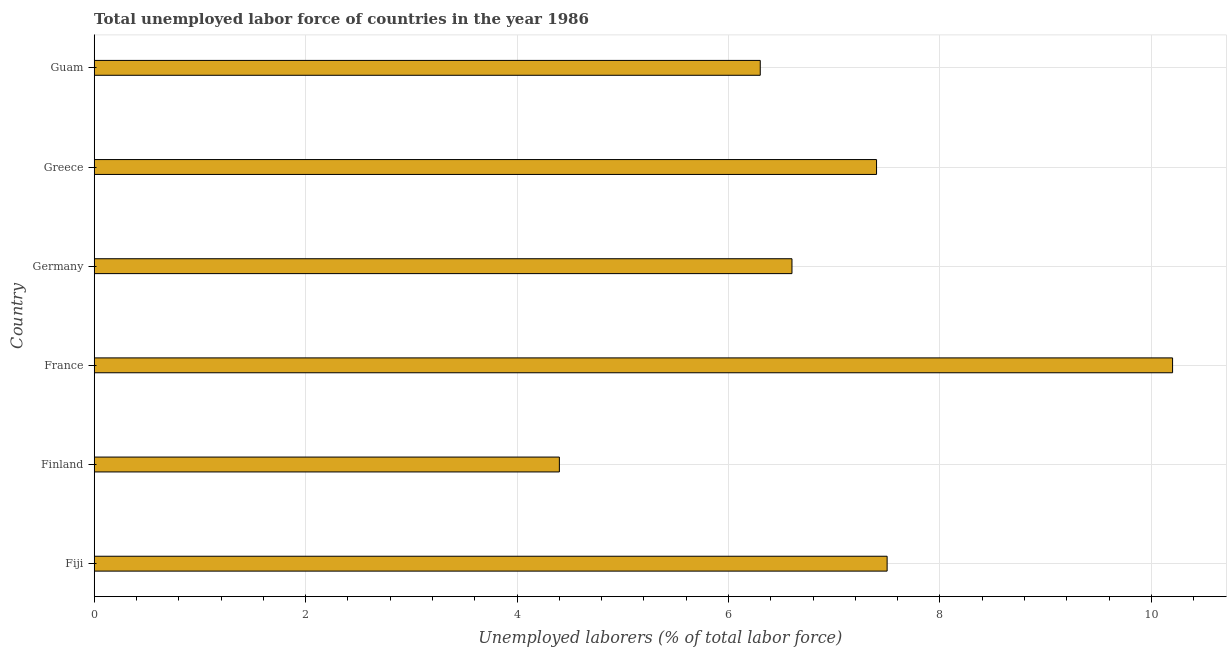Does the graph contain grids?
Your answer should be compact. Yes. What is the title of the graph?
Offer a very short reply. Total unemployed labor force of countries in the year 1986. What is the label or title of the X-axis?
Offer a terse response. Unemployed laborers (% of total labor force). What is the total unemployed labour force in Germany?
Keep it short and to the point. 6.6. Across all countries, what is the maximum total unemployed labour force?
Offer a very short reply. 10.2. Across all countries, what is the minimum total unemployed labour force?
Your answer should be compact. 4.4. In which country was the total unemployed labour force minimum?
Your answer should be compact. Finland. What is the sum of the total unemployed labour force?
Keep it short and to the point. 42.4. What is the difference between the total unemployed labour force in Finland and France?
Your answer should be very brief. -5.8. What is the average total unemployed labour force per country?
Your response must be concise. 7.07. What is the ratio of the total unemployed labour force in Germany to that in Guam?
Offer a very short reply. 1.05. What is the difference between the highest and the second highest total unemployed labour force?
Provide a succinct answer. 2.7. Is the sum of the total unemployed labour force in Fiji and Guam greater than the maximum total unemployed labour force across all countries?
Provide a succinct answer. Yes. What is the difference between the highest and the lowest total unemployed labour force?
Provide a succinct answer. 5.8. How many bars are there?
Your answer should be very brief. 6. What is the Unemployed laborers (% of total labor force) of Fiji?
Ensure brevity in your answer.  7.5. What is the Unemployed laborers (% of total labor force) of Finland?
Make the answer very short. 4.4. What is the Unemployed laborers (% of total labor force) of France?
Provide a short and direct response. 10.2. What is the Unemployed laborers (% of total labor force) of Germany?
Your response must be concise. 6.6. What is the Unemployed laborers (% of total labor force) in Greece?
Keep it short and to the point. 7.4. What is the Unemployed laborers (% of total labor force) in Guam?
Make the answer very short. 6.3. What is the difference between the Unemployed laborers (% of total labor force) in Fiji and Finland?
Ensure brevity in your answer.  3.1. What is the difference between the Unemployed laborers (% of total labor force) in Fiji and Germany?
Ensure brevity in your answer.  0.9. What is the difference between the Unemployed laborers (% of total labor force) in Fiji and Greece?
Your answer should be very brief. 0.1. What is the difference between the Unemployed laborers (% of total labor force) in Fiji and Guam?
Your response must be concise. 1.2. What is the difference between the Unemployed laborers (% of total labor force) in Finland and France?
Make the answer very short. -5.8. What is the difference between the Unemployed laborers (% of total labor force) in Finland and Greece?
Your response must be concise. -3. What is the difference between the Unemployed laborers (% of total labor force) in France and Germany?
Offer a terse response. 3.6. What is the difference between the Unemployed laborers (% of total labor force) in France and Greece?
Provide a succinct answer. 2.8. What is the difference between the Unemployed laborers (% of total labor force) in France and Guam?
Provide a short and direct response. 3.9. What is the difference between the Unemployed laborers (% of total labor force) in Germany and Guam?
Your answer should be very brief. 0.3. What is the ratio of the Unemployed laborers (% of total labor force) in Fiji to that in Finland?
Ensure brevity in your answer.  1.71. What is the ratio of the Unemployed laborers (% of total labor force) in Fiji to that in France?
Provide a short and direct response. 0.73. What is the ratio of the Unemployed laborers (% of total labor force) in Fiji to that in Germany?
Provide a short and direct response. 1.14. What is the ratio of the Unemployed laborers (% of total labor force) in Fiji to that in Greece?
Keep it short and to the point. 1.01. What is the ratio of the Unemployed laborers (% of total labor force) in Fiji to that in Guam?
Give a very brief answer. 1.19. What is the ratio of the Unemployed laborers (% of total labor force) in Finland to that in France?
Offer a very short reply. 0.43. What is the ratio of the Unemployed laborers (% of total labor force) in Finland to that in Germany?
Keep it short and to the point. 0.67. What is the ratio of the Unemployed laborers (% of total labor force) in Finland to that in Greece?
Keep it short and to the point. 0.59. What is the ratio of the Unemployed laborers (% of total labor force) in Finland to that in Guam?
Give a very brief answer. 0.7. What is the ratio of the Unemployed laborers (% of total labor force) in France to that in Germany?
Your response must be concise. 1.54. What is the ratio of the Unemployed laborers (% of total labor force) in France to that in Greece?
Your answer should be compact. 1.38. What is the ratio of the Unemployed laborers (% of total labor force) in France to that in Guam?
Provide a succinct answer. 1.62. What is the ratio of the Unemployed laborers (% of total labor force) in Germany to that in Greece?
Offer a very short reply. 0.89. What is the ratio of the Unemployed laborers (% of total labor force) in Germany to that in Guam?
Your answer should be very brief. 1.05. What is the ratio of the Unemployed laborers (% of total labor force) in Greece to that in Guam?
Your response must be concise. 1.18. 